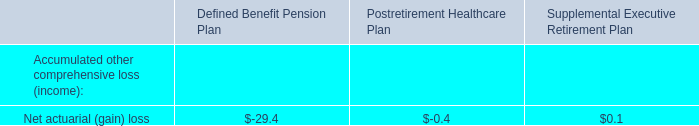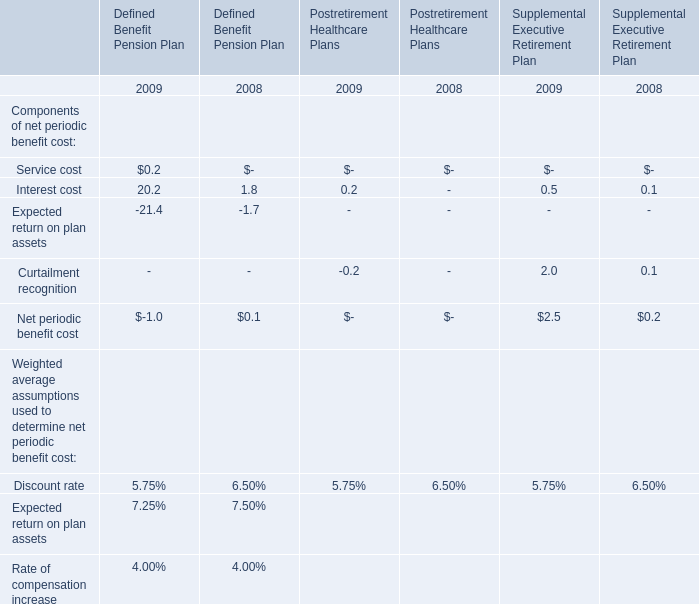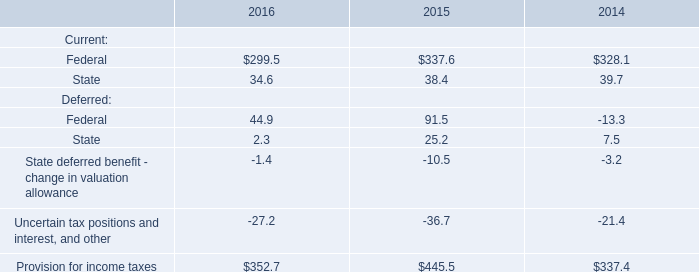As As the chart 1 shows,in the year where Interest cost for Defined Benefit Pension Plan is the most, what is the Service cost for Defined Benefit Pension Plan? 
Answer: 0.2. 